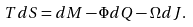Convert formula to latex. <formula><loc_0><loc_0><loc_500><loc_500>T d S = d M - \Phi d Q - \Omega d J .</formula> 